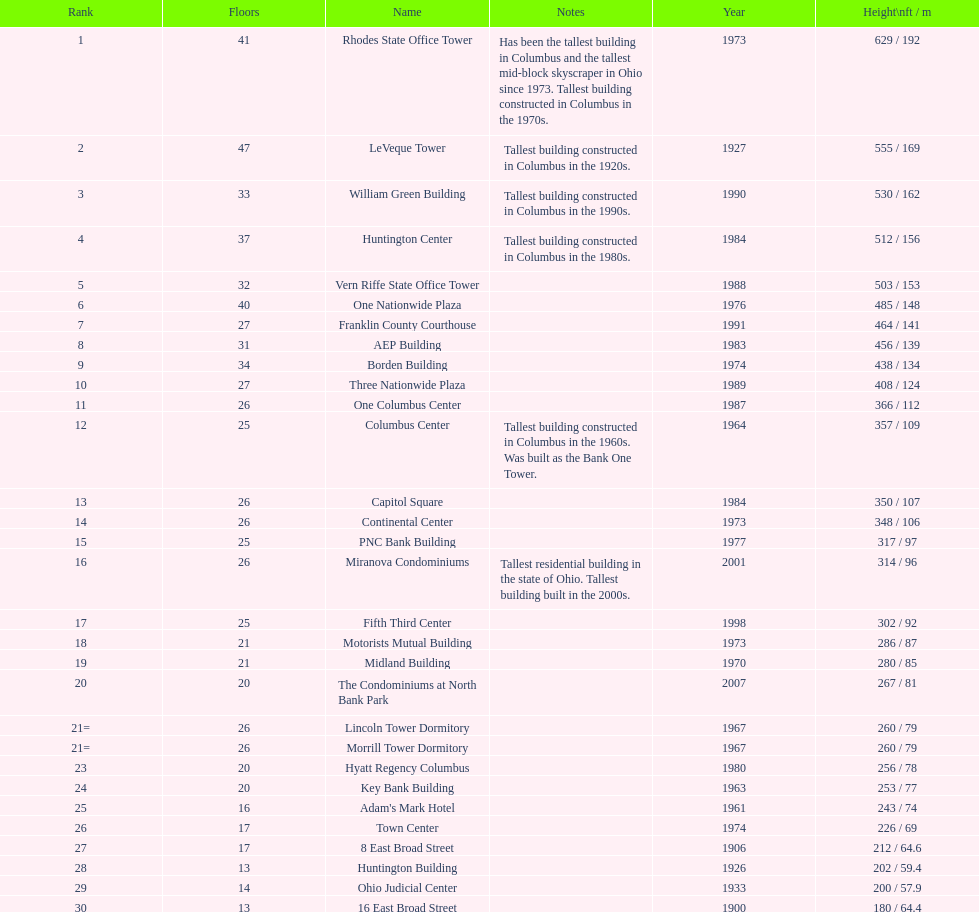What is the number of buildings under 200 ft? 1. 